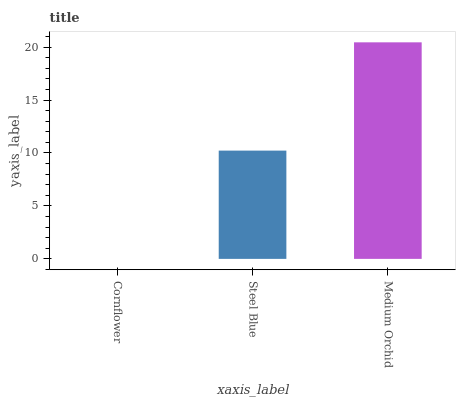Is Cornflower the minimum?
Answer yes or no. Yes. Is Medium Orchid the maximum?
Answer yes or no. Yes. Is Steel Blue the minimum?
Answer yes or no. No. Is Steel Blue the maximum?
Answer yes or no. No. Is Steel Blue greater than Cornflower?
Answer yes or no. Yes. Is Cornflower less than Steel Blue?
Answer yes or no. Yes. Is Cornflower greater than Steel Blue?
Answer yes or no. No. Is Steel Blue less than Cornflower?
Answer yes or no. No. Is Steel Blue the high median?
Answer yes or no. Yes. Is Steel Blue the low median?
Answer yes or no. Yes. Is Medium Orchid the high median?
Answer yes or no. No. Is Medium Orchid the low median?
Answer yes or no. No. 